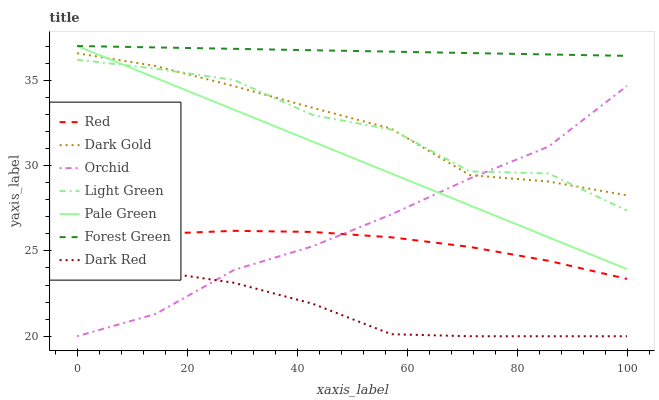Does Dark Red have the minimum area under the curve?
Answer yes or no. Yes. Does Forest Green have the maximum area under the curve?
Answer yes or no. Yes. Does Forest Green have the minimum area under the curve?
Answer yes or no. No. Does Dark Red have the maximum area under the curve?
Answer yes or no. No. Is Forest Green the smoothest?
Answer yes or no. Yes. Is Light Green the roughest?
Answer yes or no. Yes. Is Dark Red the smoothest?
Answer yes or no. No. Is Dark Red the roughest?
Answer yes or no. No. Does Dark Red have the lowest value?
Answer yes or no. Yes. Does Forest Green have the lowest value?
Answer yes or no. No. Does Pale Green have the highest value?
Answer yes or no. Yes. Does Dark Red have the highest value?
Answer yes or no. No. Is Light Green less than Forest Green?
Answer yes or no. Yes. Is Forest Green greater than Dark Gold?
Answer yes or no. Yes. Does Pale Green intersect Dark Gold?
Answer yes or no. Yes. Is Pale Green less than Dark Gold?
Answer yes or no. No. Is Pale Green greater than Dark Gold?
Answer yes or no. No. Does Light Green intersect Forest Green?
Answer yes or no. No. 